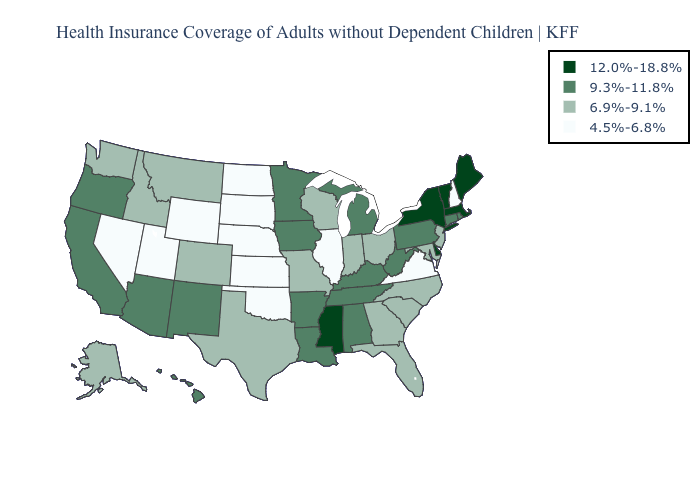Does Arkansas have the same value as Michigan?
Keep it brief. Yes. Name the states that have a value in the range 4.5%-6.8%?
Quick response, please. Illinois, Kansas, Nebraska, Nevada, New Hampshire, North Dakota, Oklahoma, South Dakota, Utah, Virginia, Wyoming. Does Vermont have the highest value in the Northeast?
Write a very short answer. Yes. Does New Hampshire have the lowest value in the Northeast?
Be succinct. Yes. What is the lowest value in the USA?
Give a very brief answer. 4.5%-6.8%. Name the states that have a value in the range 9.3%-11.8%?
Give a very brief answer. Alabama, Arizona, Arkansas, California, Connecticut, Hawaii, Iowa, Kentucky, Louisiana, Michigan, Minnesota, New Mexico, Oregon, Pennsylvania, Rhode Island, Tennessee, West Virginia. Does New Hampshire have the lowest value in the Northeast?
Keep it brief. Yes. What is the value of Massachusetts?
Short answer required. 12.0%-18.8%. What is the value of Georgia?
Be succinct. 6.9%-9.1%. How many symbols are there in the legend?
Concise answer only. 4. Among the states that border Connecticut , which have the highest value?
Quick response, please. Massachusetts, New York. Among the states that border Wyoming , does Idaho have the lowest value?
Be succinct. No. Name the states that have a value in the range 12.0%-18.8%?
Quick response, please. Delaware, Maine, Massachusetts, Mississippi, New York, Vermont. What is the value of Vermont?
Answer briefly. 12.0%-18.8%. Which states have the lowest value in the Northeast?
Write a very short answer. New Hampshire. 